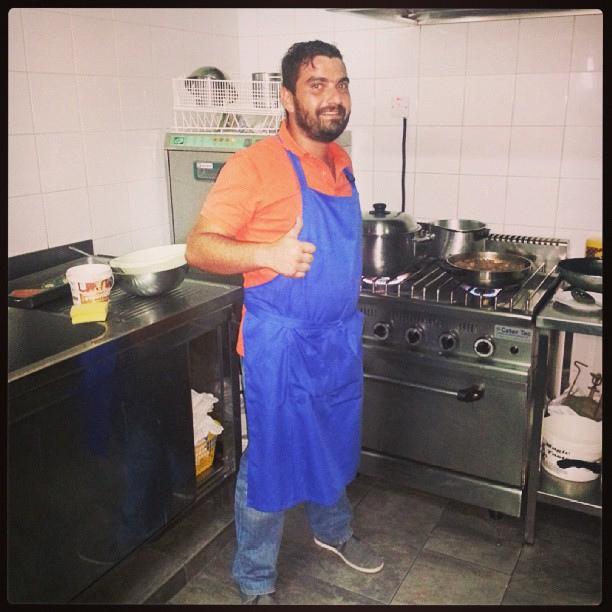Why is the man smiling?
Write a very short answer. Happy. What color is his apron?
Be succinct. Blue. Can this man get the oven as clean as it should be?
Answer briefly. Yes. Is this person wearing kitchen-safe footwear?
Keep it brief. Yes. 